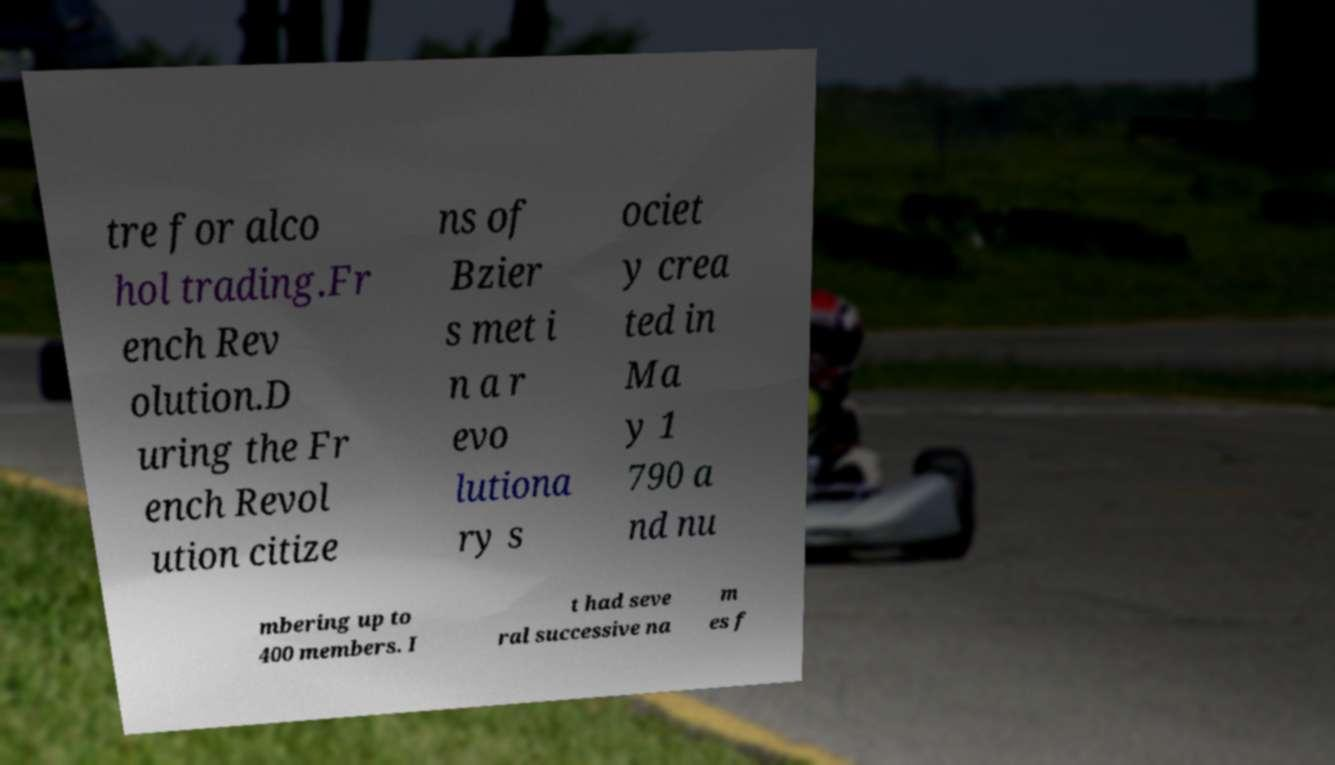Could you extract and type out the text from this image? tre for alco hol trading.Fr ench Rev olution.D uring the Fr ench Revol ution citize ns of Bzier s met i n a r evo lutiona ry s ociet y crea ted in Ma y 1 790 a nd nu mbering up to 400 members. I t had seve ral successive na m es f 